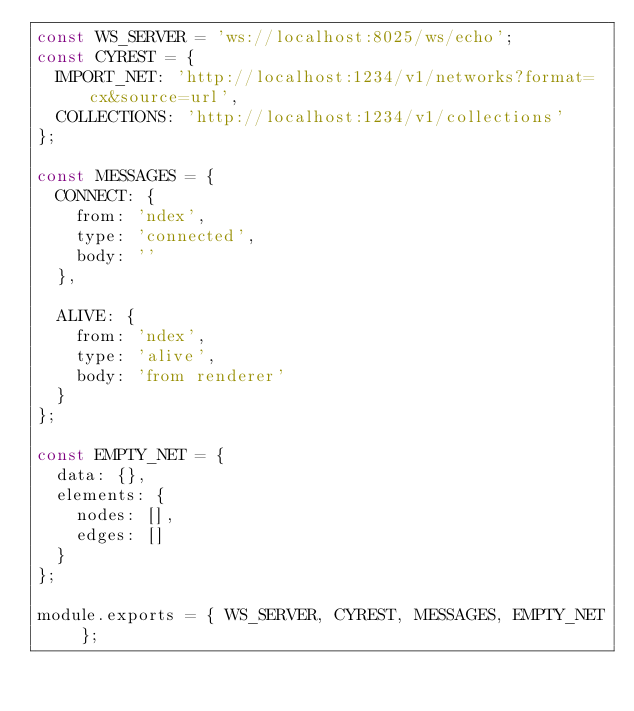<code> <loc_0><loc_0><loc_500><loc_500><_JavaScript_>const WS_SERVER = 'ws://localhost:8025/ws/echo';
const CYREST = {
  IMPORT_NET: 'http://localhost:1234/v1/networks?format=cx&source=url',
  COLLECTIONS: 'http://localhost:1234/v1/collections'
};

const MESSAGES = {
  CONNECT: {
    from: 'ndex',
    type: 'connected',
    body: ''
  },

  ALIVE: {
    from: 'ndex',
    type: 'alive',
    body: 'from renderer'
  }
};

const EMPTY_NET = {
  data: {},
  elements: {
    nodes: [],
    edges: []
  }
};

module.exports = { WS_SERVER, CYREST, MESSAGES, EMPTY_NET };
</code> 